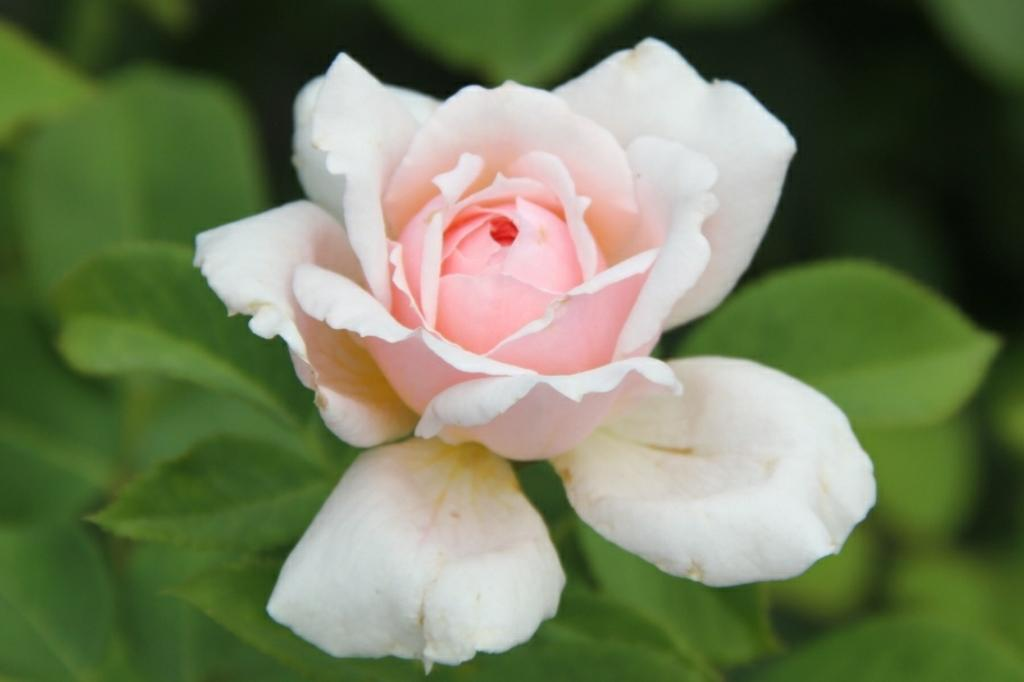What is the main subject of the image? There is a flower in the image. What color is the flower? The flower is white in color. Are there any other parts of the plant visible in the image? Yes, there are leaves associated with the flower. Can you tell me how many drinks are being served on the beach in the image? There is no beach or drinks present in the image; it features a white flower with leaves. 